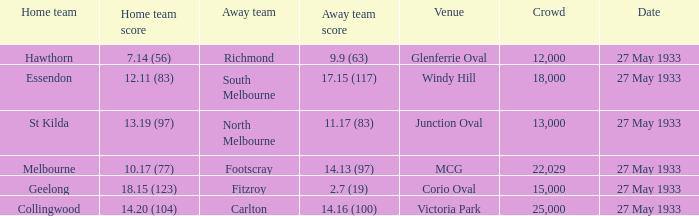7 (19), how many individuals were in the audience? 15000.0. 